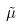<formula> <loc_0><loc_0><loc_500><loc_500>\tilde { \mu }</formula> 